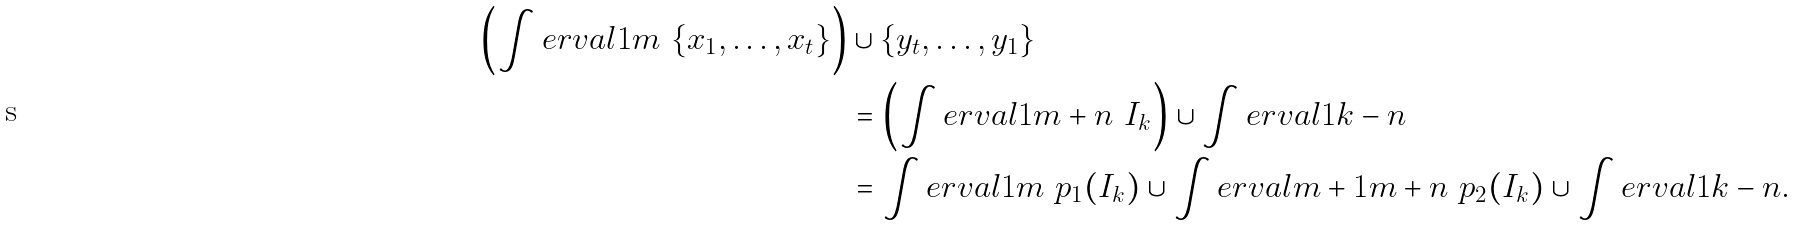<formula> <loc_0><loc_0><loc_500><loc_500>\left ( \int e r v a l { 1 } { m } \ \{ x _ { 1 } , \dots , x _ { t } \} \right ) & \cup \{ y _ { t } , \dots , y _ { 1 } \} \\ & = \left ( \int e r v a l { 1 } { m + n } \ I _ { k } \right ) \cup \int e r v a l { 1 } { k - n } \\ & = \int e r v a l { 1 } { m } \ p _ { 1 } ( I _ { k } ) \cup \int e r v a l { m + 1 } { m + n } \ p _ { 2 } ( I _ { k } ) \cup \int e r v a l { 1 } { k - n } .</formula> 